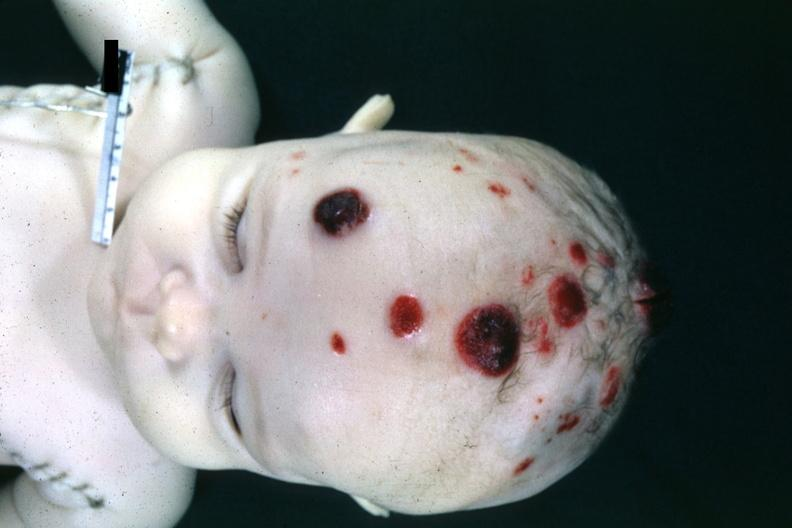what are lymphoma infiltrates 4 month old child several slides from this case are in this file?
Answer the question using a single word or phrase. Appearing skin nodules 